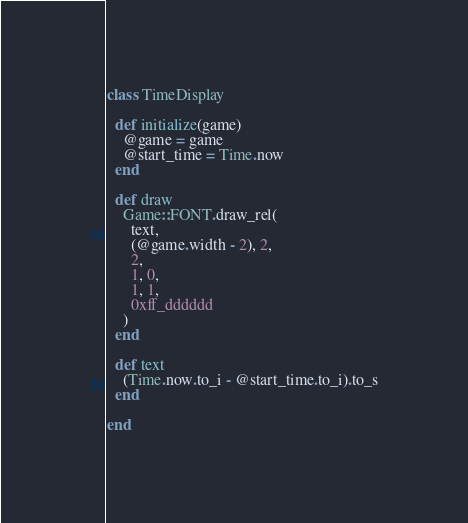<code> <loc_0><loc_0><loc_500><loc_500><_Ruby_>class TimeDisplay

  def initialize(game)
    @game = game
    @start_time = Time.now
  end

  def draw
    Game::FONT.draw_rel(
      text,
      (@game.width - 2), 2,
      2,
      1, 0,
      1, 1,
      0xff_dddddd
    )
  end

  def text
    (Time.now.to_i - @start_time.to_i).to_s
  end

end</code> 